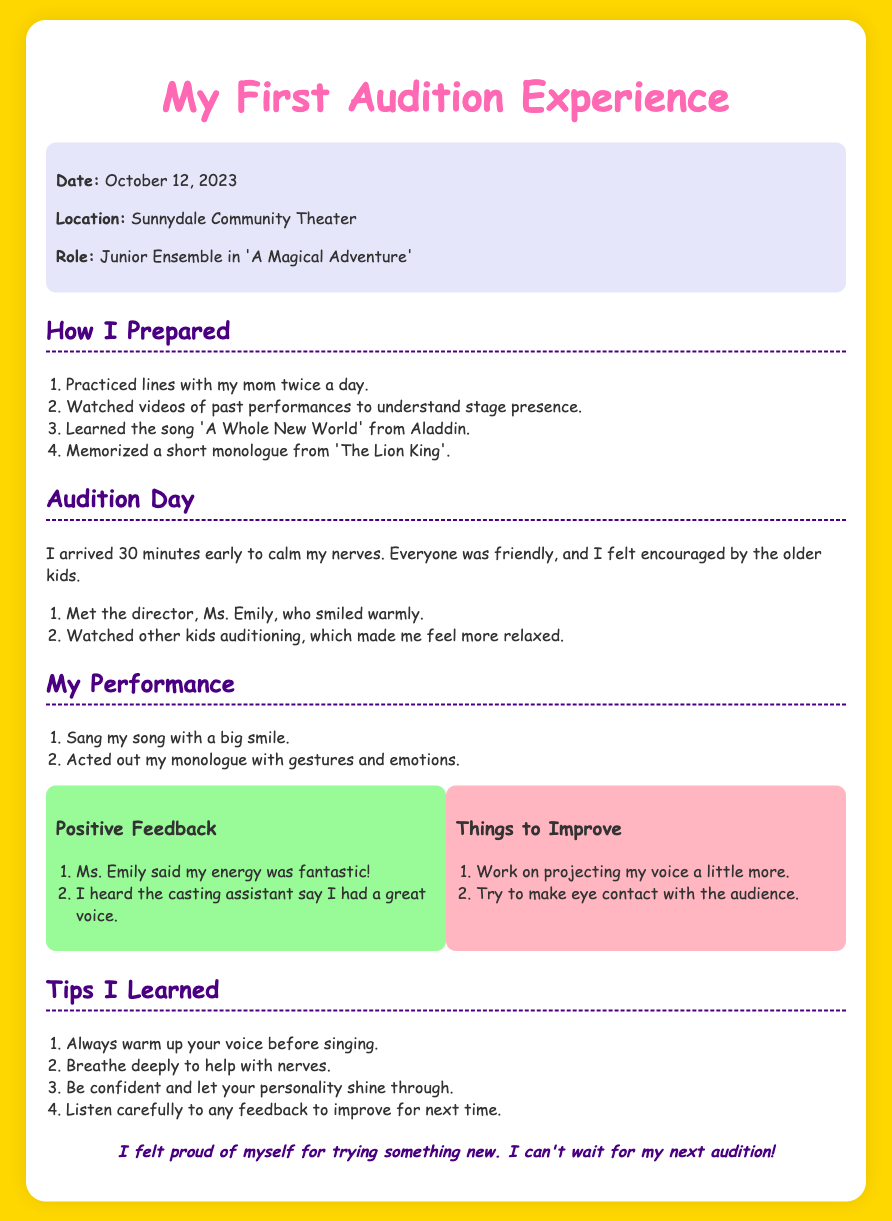What was the date of the audition? The date of the audition is clearly stated in the document under the info section.
Answer: October 12, 2023 Where did the audition take place? The location of the audition is provided in the same info section of the document.
Answer: Sunnydale Community Theater What role did I audition for? The role I was auditioning for is mentioned directly in the document.
Answer: Junior Ensemble in 'A Magical Adventure' Who is the director mentioned in the document? The name of the director is mentioned in the audition day section.
Answer: Ms. Emily What song did I learn for the audition? The song I learned is explicitly listed in the preparation section of the document.
Answer: A Whole New World What was one piece of positive feedback I received? A specific piece of positive feedback is provided in the performance section under positive feedback.
Answer: My energy was fantastic What is one thing I need to improve on? The document lists areas for improvement in the feedback section.
Answer: Projecting my voice What is one tip I learned for future auditions? The tips I learned are outlined in the tips section of the document.
Answer: Warm up your voice How did I feel after the audition? The conclusion section expresses my feelings about the experience.
Answer: Proud 